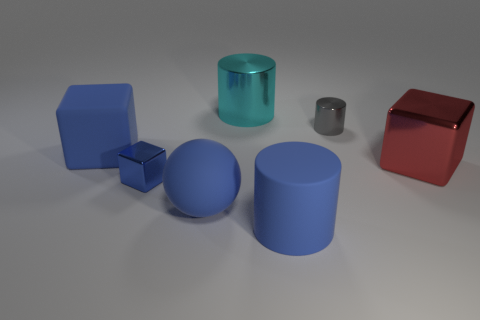What shape is the big red metallic object?
Provide a short and direct response. Cube. There is a small thing to the right of the big object that is behind the small gray shiny thing to the right of the cyan shiny thing; what is its material?
Your response must be concise. Metal. What number of other objects are the same material as the big cyan object?
Provide a succinct answer. 3. What number of big shiny blocks are in front of the small thing that is behind the tiny blue block?
Your answer should be very brief. 1. What number of cylinders are small things or blue metal objects?
Give a very brief answer. 1. There is a large matte thing that is both behind the large rubber cylinder and on the right side of the small blue shiny object; what color is it?
Your answer should be compact. Blue. Is there anything else of the same color as the sphere?
Your answer should be compact. Yes. What color is the large rubber block on the left side of the shiny cylinder to the right of the cyan cylinder?
Give a very brief answer. Blue. Do the rubber sphere and the matte cube have the same size?
Your answer should be very brief. Yes. Is the material of the large blue cube behind the big blue rubber cylinder the same as the blue cylinder to the left of the large red metal object?
Offer a terse response. Yes. 